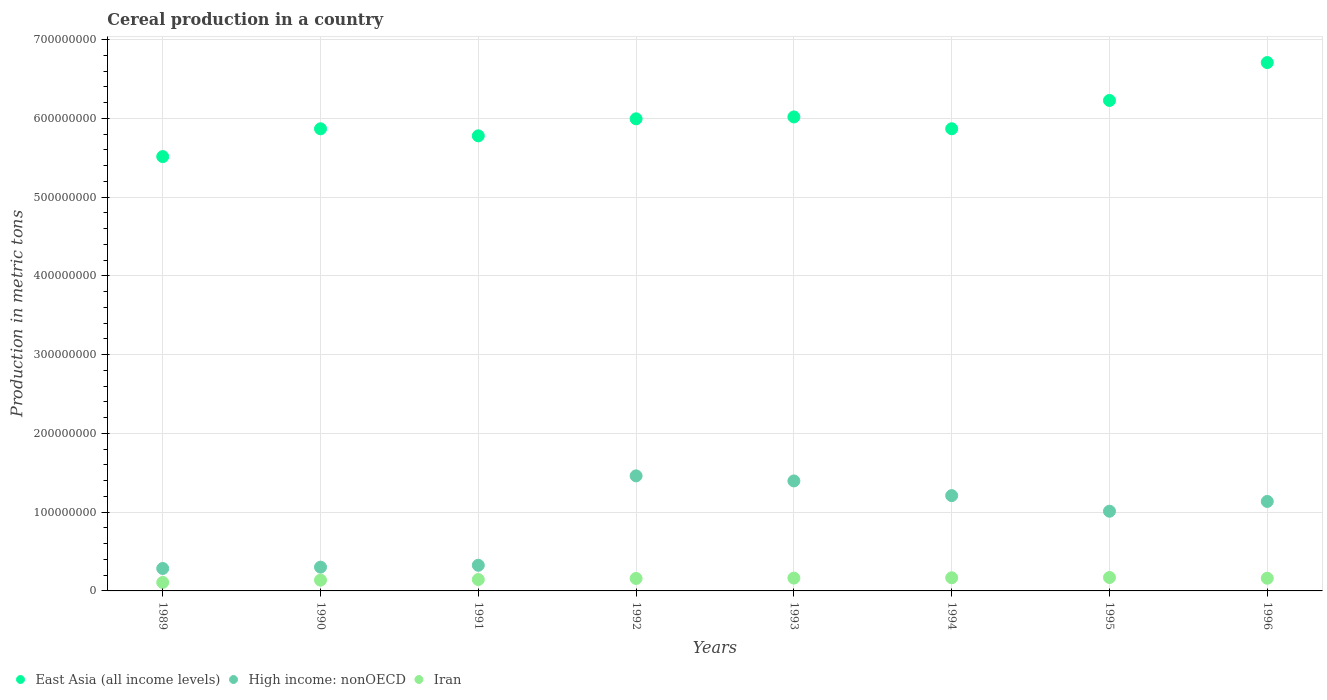What is the total cereal production in Iran in 1991?
Provide a succinct answer. 1.44e+07. Across all years, what is the maximum total cereal production in High income: nonOECD?
Provide a succinct answer. 1.46e+08. Across all years, what is the minimum total cereal production in East Asia (all income levels)?
Give a very brief answer. 5.52e+08. In which year was the total cereal production in Iran minimum?
Provide a succinct answer. 1989. What is the total total cereal production in High income: nonOECD in the graph?
Keep it short and to the point. 7.13e+08. What is the difference between the total cereal production in Iran in 1989 and that in 1996?
Ensure brevity in your answer.  -5.30e+06. What is the difference between the total cereal production in East Asia (all income levels) in 1994 and the total cereal production in High income: nonOECD in 1996?
Keep it short and to the point. 4.73e+08. What is the average total cereal production in High income: nonOECD per year?
Your response must be concise. 8.91e+07. In the year 1990, what is the difference between the total cereal production in East Asia (all income levels) and total cereal production in Iran?
Keep it short and to the point. 5.73e+08. In how many years, is the total cereal production in East Asia (all income levels) greater than 40000000 metric tons?
Keep it short and to the point. 8. What is the ratio of the total cereal production in High income: nonOECD in 1991 to that in 1995?
Your response must be concise. 0.32. Is the total cereal production in High income: nonOECD in 1994 less than that in 1996?
Offer a very short reply. No. Is the difference between the total cereal production in East Asia (all income levels) in 1990 and 1996 greater than the difference between the total cereal production in Iran in 1990 and 1996?
Your answer should be compact. No. What is the difference between the highest and the second highest total cereal production in High income: nonOECD?
Ensure brevity in your answer.  6.44e+06. What is the difference between the highest and the lowest total cereal production in Iran?
Offer a terse response. 6.25e+06. Is the sum of the total cereal production in East Asia (all income levels) in 1991 and 1992 greater than the maximum total cereal production in Iran across all years?
Offer a very short reply. Yes. Is it the case that in every year, the sum of the total cereal production in East Asia (all income levels) and total cereal production in High income: nonOECD  is greater than the total cereal production in Iran?
Your answer should be very brief. Yes. Is the total cereal production in East Asia (all income levels) strictly less than the total cereal production in High income: nonOECD over the years?
Give a very brief answer. No. How many dotlines are there?
Provide a short and direct response. 3. What is the difference between two consecutive major ticks on the Y-axis?
Your answer should be very brief. 1.00e+08. Are the values on the major ticks of Y-axis written in scientific E-notation?
Your answer should be very brief. No. Does the graph contain grids?
Ensure brevity in your answer.  Yes. How are the legend labels stacked?
Your answer should be very brief. Horizontal. What is the title of the graph?
Your answer should be compact. Cereal production in a country. Does "Tonga" appear as one of the legend labels in the graph?
Your answer should be compact. No. What is the label or title of the Y-axis?
Ensure brevity in your answer.  Production in metric tons. What is the Production in metric tons of East Asia (all income levels) in 1989?
Keep it short and to the point. 5.52e+08. What is the Production in metric tons of High income: nonOECD in 1989?
Provide a short and direct response. 2.85e+07. What is the Production in metric tons in Iran in 1989?
Make the answer very short. 1.08e+07. What is the Production in metric tons in East Asia (all income levels) in 1990?
Provide a succinct answer. 5.87e+08. What is the Production in metric tons of High income: nonOECD in 1990?
Keep it short and to the point. 3.02e+07. What is the Production in metric tons in Iran in 1990?
Offer a very short reply. 1.37e+07. What is the Production in metric tons in East Asia (all income levels) in 1991?
Provide a short and direct response. 5.78e+08. What is the Production in metric tons of High income: nonOECD in 1991?
Give a very brief answer. 3.26e+07. What is the Production in metric tons of Iran in 1991?
Offer a very short reply. 1.44e+07. What is the Production in metric tons of East Asia (all income levels) in 1992?
Your answer should be compact. 6.00e+08. What is the Production in metric tons of High income: nonOECD in 1992?
Make the answer very short. 1.46e+08. What is the Production in metric tons of Iran in 1992?
Your response must be concise. 1.58e+07. What is the Production in metric tons of East Asia (all income levels) in 1993?
Make the answer very short. 6.02e+08. What is the Production in metric tons in High income: nonOECD in 1993?
Ensure brevity in your answer.  1.40e+08. What is the Production in metric tons in Iran in 1993?
Your answer should be very brief. 1.63e+07. What is the Production in metric tons in East Asia (all income levels) in 1994?
Ensure brevity in your answer.  5.87e+08. What is the Production in metric tons of High income: nonOECD in 1994?
Your answer should be compact. 1.21e+08. What is the Production in metric tons of Iran in 1994?
Ensure brevity in your answer.  1.67e+07. What is the Production in metric tons of East Asia (all income levels) in 1995?
Ensure brevity in your answer.  6.23e+08. What is the Production in metric tons in High income: nonOECD in 1995?
Make the answer very short. 1.01e+08. What is the Production in metric tons in Iran in 1995?
Keep it short and to the point. 1.70e+07. What is the Production in metric tons of East Asia (all income levels) in 1996?
Make the answer very short. 6.71e+08. What is the Production in metric tons of High income: nonOECD in 1996?
Give a very brief answer. 1.14e+08. What is the Production in metric tons of Iran in 1996?
Your answer should be compact. 1.61e+07. Across all years, what is the maximum Production in metric tons in East Asia (all income levels)?
Provide a short and direct response. 6.71e+08. Across all years, what is the maximum Production in metric tons in High income: nonOECD?
Ensure brevity in your answer.  1.46e+08. Across all years, what is the maximum Production in metric tons in Iran?
Make the answer very short. 1.70e+07. Across all years, what is the minimum Production in metric tons of East Asia (all income levels)?
Provide a succinct answer. 5.52e+08. Across all years, what is the minimum Production in metric tons of High income: nonOECD?
Ensure brevity in your answer.  2.85e+07. Across all years, what is the minimum Production in metric tons in Iran?
Ensure brevity in your answer.  1.08e+07. What is the total Production in metric tons in East Asia (all income levels) in the graph?
Your answer should be very brief. 4.80e+09. What is the total Production in metric tons in High income: nonOECD in the graph?
Your answer should be very brief. 7.13e+08. What is the total Production in metric tons of Iran in the graph?
Give a very brief answer. 1.21e+08. What is the difference between the Production in metric tons of East Asia (all income levels) in 1989 and that in 1990?
Provide a short and direct response. -3.53e+07. What is the difference between the Production in metric tons in High income: nonOECD in 1989 and that in 1990?
Your response must be concise. -1.70e+06. What is the difference between the Production in metric tons in Iran in 1989 and that in 1990?
Give a very brief answer. -2.90e+06. What is the difference between the Production in metric tons of East Asia (all income levels) in 1989 and that in 1991?
Your response must be concise. -2.64e+07. What is the difference between the Production in metric tons of High income: nonOECD in 1989 and that in 1991?
Offer a terse response. -4.07e+06. What is the difference between the Production in metric tons of Iran in 1989 and that in 1991?
Ensure brevity in your answer.  -3.66e+06. What is the difference between the Production in metric tons of East Asia (all income levels) in 1989 and that in 1992?
Your answer should be very brief. -4.80e+07. What is the difference between the Production in metric tons of High income: nonOECD in 1989 and that in 1992?
Offer a terse response. -1.18e+08. What is the difference between the Production in metric tons in Iran in 1989 and that in 1992?
Make the answer very short. -5.02e+06. What is the difference between the Production in metric tons in East Asia (all income levels) in 1989 and that in 1993?
Your answer should be very brief. -5.04e+07. What is the difference between the Production in metric tons in High income: nonOECD in 1989 and that in 1993?
Your answer should be very brief. -1.11e+08. What is the difference between the Production in metric tons of Iran in 1989 and that in 1993?
Provide a succinct answer. -5.50e+06. What is the difference between the Production in metric tons in East Asia (all income levels) in 1989 and that in 1994?
Offer a very short reply. -3.54e+07. What is the difference between the Production in metric tons in High income: nonOECD in 1989 and that in 1994?
Give a very brief answer. -9.25e+07. What is the difference between the Production in metric tons in Iran in 1989 and that in 1994?
Make the answer very short. -5.90e+06. What is the difference between the Production in metric tons of East Asia (all income levels) in 1989 and that in 1995?
Give a very brief answer. -7.13e+07. What is the difference between the Production in metric tons in High income: nonOECD in 1989 and that in 1995?
Ensure brevity in your answer.  -7.27e+07. What is the difference between the Production in metric tons of Iran in 1989 and that in 1995?
Provide a succinct answer. -6.25e+06. What is the difference between the Production in metric tons in East Asia (all income levels) in 1989 and that in 1996?
Offer a terse response. -1.19e+08. What is the difference between the Production in metric tons of High income: nonOECD in 1989 and that in 1996?
Make the answer very short. -8.51e+07. What is the difference between the Production in metric tons of Iran in 1989 and that in 1996?
Keep it short and to the point. -5.30e+06. What is the difference between the Production in metric tons of East Asia (all income levels) in 1990 and that in 1991?
Make the answer very short. 8.95e+06. What is the difference between the Production in metric tons of High income: nonOECD in 1990 and that in 1991?
Your answer should be compact. -2.37e+06. What is the difference between the Production in metric tons in Iran in 1990 and that in 1991?
Provide a succinct answer. -7.63e+05. What is the difference between the Production in metric tons of East Asia (all income levels) in 1990 and that in 1992?
Ensure brevity in your answer.  -1.27e+07. What is the difference between the Production in metric tons in High income: nonOECD in 1990 and that in 1992?
Provide a short and direct response. -1.16e+08. What is the difference between the Production in metric tons in Iran in 1990 and that in 1992?
Your answer should be compact. -2.13e+06. What is the difference between the Production in metric tons of East Asia (all income levels) in 1990 and that in 1993?
Offer a terse response. -1.50e+07. What is the difference between the Production in metric tons of High income: nonOECD in 1990 and that in 1993?
Your answer should be compact. -1.09e+08. What is the difference between the Production in metric tons in Iran in 1990 and that in 1993?
Offer a terse response. -2.60e+06. What is the difference between the Production in metric tons in East Asia (all income levels) in 1990 and that in 1994?
Provide a succinct answer. -3.81e+04. What is the difference between the Production in metric tons in High income: nonOECD in 1990 and that in 1994?
Offer a terse response. -9.08e+07. What is the difference between the Production in metric tons in Iran in 1990 and that in 1994?
Your answer should be very brief. -3.01e+06. What is the difference between the Production in metric tons in East Asia (all income levels) in 1990 and that in 1995?
Provide a succinct answer. -3.60e+07. What is the difference between the Production in metric tons of High income: nonOECD in 1990 and that in 1995?
Provide a short and direct response. -7.10e+07. What is the difference between the Production in metric tons in Iran in 1990 and that in 1995?
Provide a short and direct response. -3.35e+06. What is the difference between the Production in metric tons of East Asia (all income levels) in 1990 and that in 1996?
Provide a short and direct response. -8.41e+07. What is the difference between the Production in metric tons in High income: nonOECD in 1990 and that in 1996?
Provide a succinct answer. -8.34e+07. What is the difference between the Production in metric tons in Iran in 1990 and that in 1996?
Offer a very short reply. -2.40e+06. What is the difference between the Production in metric tons in East Asia (all income levels) in 1991 and that in 1992?
Provide a short and direct response. -2.16e+07. What is the difference between the Production in metric tons in High income: nonOECD in 1991 and that in 1992?
Provide a succinct answer. -1.14e+08. What is the difference between the Production in metric tons in Iran in 1991 and that in 1992?
Give a very brief answer. -1.36e+06. What is the difference between the Production in metric tons in East Asia (all income levels) in 1991 and that in 1993?
Ensure brevity in your answer.  -2.40e+07. What is the difference between the Production in metric tons of High income: nonOECD in 1991 and that in 1993?
Your answer should be very brief. -1.07e+08. What is the difference between the Production in metric tons of Iran in 1991 and that in 1993?
Your answer should be compact. -1.84e+06. What is the difference between the Production in metric tons in East Asia (all income levels) in 1991 and that in 1994?
Your answer should be compact. -8.99e+06. What is the difference between the Production in metric tons of High income: nonOECD in 1991 and that in 1994?
Keep it short and to the point. -8.85e+07. What is the difference between the Production in metric tons in Iran in 1991 and that in 1994?
Ensure brevity in your answer.  -2.24e+06. What is the difference between the Production in metric tons in East Asia (all income levels) in 1991 and that in 1995?
Give a very brief answer. -4.49e+07. What is the difference between the Production in metric tons in High income: nonOECD in 1991 and that in 1995?
Your response must be concise. -6.86e+07. What is the difference between the Production in metric tons in Iran in 1991 and that in 1995?
Your answer should be very brief. -2.58e+06. What is the difference between the Production in metric tons in East Asia (all income levels) in 1991 and that in 1996?
Provide a short and direct response. -9.30e+07. What is the difference between the Production in metric tons in High income: nonOECD in 1991 and that in 1996?
Offer a terse response. -8.11e+07. What is the difference between the Production in metric tons in Iran in 1991 and that in 1996?
Offer a terse response. -1.64e+06. What is the difference between the Production in metric tons in East Asia (all income levels) in 1992 and that in 1993?
Provide a short and direct response. -2.39e+06. What is the difference between the Production in metric tons in High income: nonOECD in 1992 and that in 1993?
Your response must be concise. 6.44e+06. What is the difference between the Production in metric tons of Iran in 1992 and that in 1993?
Provide a short and direct response. -4.76e+05. What is the difference between the Production in metric tons of East Asia (all income levels) in 1992 and that in 1994?
Provide a succinct answer. 1.26e+07. What is the difference between the Production in metric tons of High income: nonOECD in 1992 and that in 1994?
Keep it short and to the point. 2.51e+07. What is the difference between the Production in metric tons in Iran in 1992 and that in 1994?
Your answer should be compact. -8.80e+05. What is the difference between the Production in metric tons of East Asia (all income levels) in 1992 and that in 1995?
Offer a very short reply. -2.33e+07. What is the difference between the Production in metric tons in High income: nonOECD in 1992 and that in 1995?
Provide a short and direct response. 4.49e+07. What is the difference between the Production in metric tons in Iran in 1992 and that in 1995?
Provide a short and direct response. -1.22e+06. What is the difference between the Production in metric tons of East Asia (all income levels) in 1992 and that in 1996?
Offer a terse response. -7.14e+07. What is the difference between the Production in metric tons in High income: nonOECD in 1992 and that in 1996?
Provide a short and direct response. 3.25e+07. What is the difference between the Production in metric tons in Iran in 1992 and that in 1996?
Provide a short and direct response. -2.72e+05. What is the difference between the Production in metric tons in East Asia (all income levels) in 1993 and that in 1994?
Make the answer very short. 1.50e+07. What is the difference between the Production in metric tons of High income: nonOECD in 1993 and that in 1994?
Keep it short and to the point. 1.86e+07. What is the difference between the Production in metric tons of Iran in 1993 and that in 1994?
Offer a terse response. -4.04e+05. What is the difference between the Production in metric tons of East Asia (all income levels) in 1993 and that in 1995?
Keep it short and to the point. -2.10e+07. What is the difference between the Production in metric tons of High income: nonOECD in 1993 and that in 1995?
Provide a succinct answer. 3.85e+07. What is the difference between the Production in metric tons in Iran in 1993 and that in 1995?
Give a very brief answer. -7.44e+05. What is the difference between the Production in metric tons of East Asia (all income levels) in 1993 and that in 1996?
Ensure brevity in your answer.  -6.91e+07. What is the difference between the Production in metric tons in High income: nonOECD in 1993 and that in 1996?
Offer a very short reply. 2.61e+07. What is the difference between the Production in metric tons of Iran in 1993 and that in 1996?
Your response must be concise. 2.04e+05. What is the difference between the Production in metric tons in East Asia (all income levels) in 1994 and that in 1995?
Keep it short and to the point. -3.60e+07. What is the difference between the Production in metric tons of High income: nonOECD in 1994 and that in 1995?
Offer a terse response. 1.98e+07. What is the difference between the Production in metric tons of Iran in 1994 and that in 1995?
Keep it short and to the point. -3.41e+05. What is the difference between the Production in metric tons in East Asia (all income levels) in 1994 and that in 1996?
Your answer should be very brief. -8.41e+07. What is the difference between the Production in metric tons of High income: nonOECD in 1994 and that in 1996?
Ensure brevity in your answer.  7.41e+06. What is the difference between the Production in metric tons of Iran in 1994 and that in 1996?
Provide a succinct answer. 6.08e+05. What is the difference between the Production in metric tons of East Asia (all income levels) in 1995 and that in 1996?
Offer a very short reply. -4.81e+07. What is the difference between the Production in metric tons of High income: nonOECD in 1995 and that in 1996?
Provide a short and direct response. -1.24e+07. What is the difference between the Production in metric tons of Iran in 1995 and that in 1996?
Ensure brevity in your answer.  9.49e+05. What is the difference between the Production in metric tons in East Asia (all income levels) in 1989 and the Production in metric tons in High income: nonOECD in 1990?
Give a very brief answer. 5.21e+08. What is the difference between the Production in metric tons of East Asia (all income levels) in 1989 and the Production in metric tons of Iran in 1990?
Offer a very short reply. 5.38e+08. What is the difference between the Production in metric tons in High income: nonOECD in 1989 and the Production in metric tons in Iran in 1990?
Your response must be concise. 1.48e+07. What is the difference between the Production in metric tons in East Asia (all income levels) in 1989 and the Production in metric tons in High income: nonOECD in 1991?
Your answer should be compact. 5.19e+08. What is the difference between the Production in metric tons of East Asia (all income levels) in 1989 and the Production in metric tons of Iran in 1991?
Offer a terse response. 5.37e+08. What is the difference between the Production in metric tons of High income: nonOECD in 1989 and the Production in metric tons of Iran in 1991?
Provide a succinct answer. 1.40e+07. What is the difference between the Production in metric tons in East Asia (all income levels) in 1989 and the Production in metric tons in High income: nonOECD in 1992?
Your response must be concise. 4.05e+08. What is the difference between the Production in metric tons of East Asia (all income levels) in 1989 and the Production in metric tons of Iran in 1992?
Provide a succinct answer. 5.36e+08. What is the difference between the Production in metric tons of High income: nonOECD in 1989 and the Production in metric tons of Iran in 1992?
Keep it short and to the point. 1.27e+07. What is the difference between the Production in metric tons in East Asia (all income levels) in 1989 and the Production in metric tons in High income: nonOECD in 1993?
Keep it short and to the point. 4.12e+08. What is the difference between the Production in metric tons of East Asia (all income levels) in 1989 and the Production in metric tons of Iran in 1993?
Your answer should be compact. 5.35e+08. What is the difference between the Production in metric tons in High income: nonOECD in 1989 and the Production in metric tons in Iran in 1993?
Your response must be concise. 1.22e+07. What is the difference between the Production in metric tons in East Asia (all income levels) in 1989 and the Production in metric tons in High income: nonOECD in 1994?
Your answer should be compact. 4.31e+08. What is the difference between the Production in metric tons of East Asia (all income levels) in 1989 and the Production in metric tons of Iran in 1994?
Ensure brevity in your answer.  5.35e+08. What is the difference between the Production in metric tons of High income: nonOECD in 1989 and the Production in metric tons of Iran in 1994?
Ensure brevity in your answer.  1.18e+07. What is the difference between the Production in metric tons in East Asia (all income levels) in 1989 and the Production in metric tons in High income: nonOECD in 1995?
Your response must be concise. 4.50e+08. What is the difference between the Production in metric tons in East Asia (all income levels) in 1989 and the Production in metric tons in Iran in 1995?
Your response must be concise. 5.35e+08. What is the difference between the Production in metric tons of High income: nonOECD in 1989 and the Production in metric tons of Iran in 1995?
Ensure brevity in your answer.  1.15e+07. What is the difference between the Production in metric tons in East Asia (all income levels) in 1989 and the Production in metric tons in High income: nonOECD in 1996?
Offer a very short reply. 4.38e+08. What is the difference between the Production in metric tons of East Asia (all income levels) in 1989 and the Production in metric tons of Iran in 1996?
Give a very brief answer. 5.35e+08. What is the difference between the Production in metric tons of High income: nonOECD in 1989 and the Production in metric tons of Iran in 1996?
Offer a very short reply. 1.24e+07. What is the difference between the Production in metric tons in East Asia (all income levels) in 1990 and the Production in metric tons in High income: nonOECD in 1991?
Provide a short and direct response. 5.54e+08. What is the difference between the Production in metric tons of East Asia (all income levels) in 1990 and the Production in metric tons of Iran in 1991?
Offer a very short reply. 5.72e+08. What is the difference between the Production in metric tons of High income: nonOECD in 1990 and the Production in metric tons of Iran in 1991?
Keep it short and to the point. 1.57e+07. What is the difference between the Production in metric tons in East Asia (all income levels) in 1990 and the Production in metric tons in High income: nonOECD in 1992?
Your answer should be very brief. 4.41e+08. What is the difference between the Production in metric tons of East Asia (all income levels) in 1990 and the Production in metric tons of Iran in 1992?
Your answer should be very brief. 5.71e+08. What is the difference between the Production in metric tons in High income: nonOECD in 1990 and the Production in metric tons in Iran in 1992?
Your answer should be compact. 1.44e+07. What is the difference between the Production in metric tons of East Asia (all income levels) in 1990 and the Production in metric tons of High income: nonOECD in 1993?
Keep it short and to the point. 4.47e+08. What is the difference between the Production in metric tons in East Asia (all income levels) in 1990 and the Production in metric tons in Iran in 1993?
Make the answer very short. 5.71e+08. What is the difference between the Production in metric tons in High income: nonOECD in 1990 and the Production in metric tons in Iran in 1993?
Give a very brief answer. 1.39e+07. What is the difference between the Production in metric tons of East Asia (all income levels) in 1990 and the Production in metric tons of High income: nonOECD in 1994?
Offer a terse response. 4.66e+08. What is the difference between the Production in metric tons in East Asia (all income levels) in 1990 and the Production in metric tons in Iran in 1994?
Your response must be concise. 5.70e+08. What is the difference between the Production in metric tons of High income: nonOECD in 1990 and the Production in metric tons of Iran in 1994?
Give a very brief answer. 1.35e+07. What is the difference between the Production in metric tons of East Asia (all income levels) in 1990 and the Production in metric tons of High income: nonOECD in 1995?
Offer a very short reply. 4.86e+08. What is the difference between the Production in metric tons of East Asia (all income levels) in 1990 and the Production in metric tons of Iran in 1995?
Make the answer very short. 5.70e+08. What is the difference between the Production in metric tons in High income: nonOECD in 1990 and the Production in metric tons in Iran in 1995?
Your answer should be compact. 1.32e+07. What is the difference between the Production in metric tons of East Asia (all income levels) in 1990 and the Production in metric tons of High income: nonOECD in 1996?
Keep it short and to the point. 4.73e+08. What is the difference between the Production in metric tons in East Asia (all income levels) in 1990 and the Production in metric tons in Iran in 1996?
Your response must be concise. 5.71e+08. What is the difference between the Production in metric tons of High income: nonOECD in 1990 and the Production in metric tons of Iran in 1996?
Provide a succinct answer. 1.41e+07. What is the difference between the Production in metric tons of East Asia (all income levels) in 1991 and the Production in metric tons of High income: nonOECD in 1992?
Keep it short and to the point. 4.32e+08. What is the difference between the Production in metric tons in East Asia (all income levels) in 1991 and the Production in metric tons in Iran in 1992?
Provide a succinct answer. 5.62e+08. What is the difference between the Production in metric tons in High income: nonOECD in 1991 and the Production in metric tons in Iran in 1992?
Your response must be concise. 1.68e+07. What is the difference between the Production in metric tons of East Asia (all income levels) in 1991 and the Production in metric tons of High income: nonOECD in 1993?
Offer a terse response. 4.38e+08. What is the difference between the Production in metric tons of East Asia (all income levels) in 1991 and the Production in metric tons of Iran in 1993?
Provide a short and direct response. 5.62e+08. What is the difference between the Production in metric tons in High income: nonOECD in 1991 and the Production in metric tons in Iran in 1993?
Offer a terse response. 1.63e+07. What is the difference between the Production in metric tons in East Asia (all income levels) in 1991 and the Production in metric tons in High income: nonOECD in 1994?
Provide a short and direct response. 4.57e+08. What is the difference between the Production in metric tons of East Asia (all income levels) in 1991 and the Production in metric tons of Iran in 1994?
Your response must be concise. 5.61e+08. What is the difference between the Production in metric tons of High income: nonOECD in 1991 and the Production in metric tons of Iran in 1994?
Your response must be concise. 1.59e+07. What is the difference between the Production in metric tons in East Asia (all income levels) in 1991 and the Production in metric tons in High income: nonOECD in 1995?
Offer a very short reply. 4.77e+08. What is the difference between the Production in metric tons in East Asia (all income levels) in 1991 and the Production in metric tons in Iran in 1995?
Keep it short and to the point. 5.61e+08. What is the difference between the Production in metric tons of High income: nonOECD in 1991 and the Production in metric tons of Iran in 1995?
Offer a terse response. 1.55e+07. What is the difference between the Production in metric tons in East Asia (all income levels) in 1991 and the Production in metric tons in High income: nonOECD in 1996?
Your response must be concise. 4.64e+08. What is the difference between the Production in metric tons in East Asia (all income levels) in 1991 and the Production in metric tons in Iran in 1996?
Your answer should be compact. 5.62e+08. What is the difference between the Production in metric tons in High income: nonOECD in 1991 and the Production in metric tons in Iran in 1996?
Offer a terse response. 1.65e+07. What is the difference between the Production in metric tons of East Asia (all income levels) in 1992 and the Production in metric tons of High income: nonOECD in 1993?
Provide a succinct answer. 4.60e+08. What is the difference between the Production in metric tons in East Asia (all income levels) in 1992 and the Production in metric tons in Iran in 1993?
Give a very brief answer. 5.83e+08. What is the difference between the Production in metric tons in High income: nonOECD in 1992 and the Production in metric tons in Iran in 1993?
Keep it short and to the point. 1.30e+08. What is the difference between the Production in metric tons in East Asia (all income levels) in 1992 and the Production in metric tons in High income: nonOECD in 1994?
Give a very brief answer. 4.79e+08. What is the difference between the Production in metric tons in East Asia (all income levels) in 1992 and the Production in metric tons in Iran in 1994?
Make the answer very short. 5.83e+08. What is the difference between the Production in metric tons in High income: nonOECD in 1992 and the Production in metric tons in Iran in 1994?
Make the answer very short. 1.29e+08. What is the difference between the Production in metric tons of East Asia (all income levels) in 1992 and the Production in metric tons of High income: nonOECD in 1995?
Keep it short and to the point. 4.98e+08. What is the difference between the Production in metric tons of East Asia (all income levels) in 1992 and the Production in metric tons of Iran in 1995?
Ensure brevity in your answer.  5.83e+08. What is the difference between the Production in metric tons of High income: nonOECD in 1992 and the Production in metric tons of Iran in 1995?
Provide a short and direct response. 1.29e+08. What is the difference between the Production in metric tons of East Asia (all income levels) in 1992 and the Production in metric tons of High income: nonOECD in 1996?
Provide a succinct answer. 4.86e+08. What is the difference between the Production in metric tons of East Asia (all income levels) in 1992 and the Production in metric tons of Iran in 1996?
Offer a very short reply. 5.83e+08. What is the difference between the Production in metric tons in High income: nonOECD in 1992 and the Production in metric tons in Iran in 1996?
Offer a very short reply. 1.30e+08. What is the difference between the Production in metric tons in East Asia (all income levels) in 1993 and the Production in metric tons in High income: nonOECD in 1994?
Provide a short and direct response. 4.81e+08. What is the difference between the Production in metric tons of East Asia (all income levels) in 1993 and the Production in metric tons of Iran in 1994?
Ensure brevity in your answer.  5.85e+08. What is the difference between the Production in metric tons of High income: nonOECD in 1993 and the Production in metric tons of Iran in 1994?
Provide a succinct answer. 1.23e+08. What is the difference between the Production in metric tons in East Asia (all income levels) in 1993 and the Production in metric tons in High income: nonOECD in 1995?
Provide a succinct answer. 5.01e+08. What is the difference between the Production in metric tons of East Asia (all income levels) in 1993 and the Production in metric tons of Iran in 1995?
Offer a very short reply. 5.85e+08. What is the difference between the Production in metric tons in High income: nonOECD in 1993 and the Production in metric tons in Iran in 1995?
Ensure brevity in your answer.  1.23e+08. What is the difference between the Production in metric tons of East Asia (all income levels) in 1993 and the Production in metric tons of High income: nonOECD in 1996?
Give a very brief answer. 4.88e+08. What is the difference between the Production in metric tons of East Asia (all income levels) in 1993 and the Production in metric tons of Iran in 1996?
Make the answer very short. 5.86e+08. What is the difference between the Production in metric tons in High income: nonOECD in 1993 and the Production in metric tons in Iran in 1996?
Provide a succinct answer. 1.24e+08. What is the difference between the Production in metric tons of East Asia (all income levels) in 1994 and the Production in metric tons of High income: nonOECD in 1995?
Give a very brief answer. 4.86e+08. What is the difference between the Production in metric tons of East Asia (all income levels) in 1994 and the Production in metric tons of Iran in 1995?
Your answer should be very brief. 5.70e+08. What is the difference between the Production in metric tons of High income: nonOECD in 1994 and the Production in metric tons of Iran in 1995?
Offer a terse response. 1.04e+08. What is the difference between the Production in metric tons in East Asia (all income levels) in 1994 and the Production in metric tons in High income: nonOECD in 1996?
Ensure brevity in your answer.  4.73e+08. What is the difference between the Production in metric tons of East Asia (all income levels) in 1994 and the Production in metric tons of Iran in 1996?
Offer a very short reply. 5.71e+08. What is the difference between the Production in metric tons of High income: nonOECD in 1994 and the Production in metric tons of Iran in 1996?
Provide a short and direct response. 1.05e+08. What is the difference between the Production in metric tons in East Asia (all income levels) in 1995 and the Production in metric tons in High income: nonOECD in 1996?
Provide a short and direct response. 5.09e+08. What is the difference between the Production in metric tons in East Asia (all income levels) in 1995 and the Production in metric tons in Iran in 1996?
Your answer should be compact. 6.07e+08. What is the difference between the Production in metric tons of High income: nonOECD in 1995 and the Production in metric tons of Iran in 1996?
Offer a terse response. 8.51e+07. What is the average Production in metric tons in East Asia (all income levels) per year?
Offer a very short reply. 6.00e+08. What is the average Production in metric tons in High income: nonOECD per year?
Provide a short and direct response. 8.91e+07. What is the average Production in metric tons in Iran per year?
Your response must be concise. 1.51e+07. In the year 1989, what is the difference between the Production in metric tons of East Asia (all income levels) and Production in metric tons of High income: nonOECD?
Ensure brevity in your answer.  5.23e+08. In the year 1989, what is the difference between the Production in metric tons in East Asia (all income levels) and Production in metric tons in Iran?
Provide a succinct answer. 5.41e+08. In the year 1989, what is the difference between the Production in metric tons of High income: nonOECD and Production in metric tons of Iran?
Ensure brevity in your answer.  1.77e+07. In the year 1990, what is the difference between the Production in metric tons in East Asia (all income levels) and Production in metric tons in High income: nonOECD?
Give a very brief answer. 5.57e+08. In the year 1990, what is the difference between the Production in metric tons of East Asia (all income levels) and Production in metric tons of Iran?
Provide a short and direct response. 5.73e+08. In the year 1990, what is the difference between the Production in metric tons in High income: nonOECD and Production in metric tons in Iran?
Provide a succinct answer. 1.65e+07. In the year 1991, what is the difference between the Production in metric tons in East Asia (all income levels) and Production in metric tons in High income: nonOECD?
Your response must be concise. 5.45e+08. In the year 1991, what is the difference between the Production in metric tons of East Asia (all income levels) and Production in metric tons of Iran?
Provide a short and direct response. 5.63e+08. In the year 1991, what is the difference between the Production in metric tons in High income: nonOECD and Production in metric tons in Iran?
Ensure brevity in your answer.  1.81e+07. In the year 1992, what is the difference between the Production in metric tons in East Asia (all income levels) and Production in metric tons in High income: nonOECD?
Your answer should be compact. 4.53e+08. In the year 1992, what is the difference between the Production in metric tons in East Asia (all income levels) and Production in metric tons in Iran?
Your answer should be very brief. 5.84e+08. In the year 1992, what is the difference between the Production in metric tons of High income: nonOECD and Production in metric tons of Iran?
Provide a succinct answer. 1.30e+08. In the year 1993, what is the difference between the Production in metric tons of East Asia (all income levels) and Production in metric tons of High income: nonOECD?
Provide a short and direct response. 4.62e+08. In the year 1993, what is the difference between the Production in metric tons of East Asia (all income levels) and Production in metric tons of Iran?
Your answer should be very brief. 5.86e+08. In the year 1993, what is the difference between the Production in metric tons of High income: nonOECD and Production in metric tons of Iran?
Provide a succinct answer. 1.23e+08. In the year 1994, what is the difference between the Production in metric tons in East Asia (all income levels) and Production in metric tons in High income: nonOECD?
Ensure brevity in your answer.  4.66e+08. In the year 1994, what is the difference between the Production in metric tons in East Asia (all income levels) and Production in metric tons in Iran?
Keep it short and to the point. 5.70e+08. In the year 1994, what is the difference between the Production in metric tons of High income: nonOECD and Production in metric tons of Iran?
Keep it short and to the point. 1.04e+08. In the year 1995, what is the difference between the Production in metric tons in East Asia (all income levels) and Production in metric tons in High income: nonOECD?
Offer a very short reply. 5.22e+08. In the year 1995, what is the difference between the Production in metric tons in East Asia (all income levels) and Production in metric tons in Iran?
Provide a short and direct response. 6.06e+08. In the year 1995, what is the difference between the Production in metric tons in High income: nonOECD and Production in metric tons in Iran?
Provide a succinct answer. 8.42e+07. In the year 1996, what is the difference between the Production in metric tons in East Asia (all income levels) and Production in metric tons in High income: nonOECD?
Offer a very short reply. 5.57e+08. In the year 1996, what is the difference between the Production in metric tons of East Asia (all income levels) and Production in metric tons of Iran?
Provide a short and direct response. 6.55e+08. In the year 1996, what is the difference between the Production in metric tons in High income: nonOECD and Production in metric tons in Iran?
Keep it short and to the point. 9.75e+07. What is the ratio of the Production in metric tons in East Asia (all income levels) in 1989 to that in 1990?
Provide a short and direct response. 0.94. What is the ratio of the Production in metric tons in High income: nonOECD in 1989 to that in 1990?
Keep it short and to the point. 0.94. What is the ratio of the Production in metric tons in Iran in 1989 to that in 1990?
Ensure brevity in your answer.  0.79. What is the ratio of the Production in metric tons in East Asia (all income levels) in 1989 to that in 1991?
Your response must be concise. 0.95. What is the ratio of the Production in metric tons of High income: nonOECD in 1989 to that in 1991?
Your response must be concise. 0.88. What is the ratio of the Production in metric tons of Iran in 1989 to that in 1991?
Your answer should be very brief. 0.75. What is the ratio of the Production in metric tons in East Asia (all income levels) in 1989 to that in 1992?
Ensure brevity in your answer.  0.92. What is the ratio of the Production in metric tons of High income: nonOECD in 1989 to that in 1992?
Provide a short and direct response. 0.2. What is the ratio of the Production in metric tons in Iran in 1989 to that in 1992?
Give a very brief answer. 0.68. What is the ratio of the Production in metric tons of East Asia (all income levels) in 1989 to that in 1993?
Make the answer very short. 0.92. What is the ratio of the Production in metric tons in High income: nonOECD in 1989 to that in 1993?
Provide a short and direct response. 0.2. What is the ratio of the Production in metric tons of Iran in 1989 to that in 1993?
Offer a very short reply. 0.66. What is the ratio of the Production in metric tons of East Asia (all income levels) in 1989 to that in 1994?
Your answer should be compact. 0.94. What is the ratio of the Production in metric tons of High income: nonOECD in 1989 to that in 1994?
Make the answer very short. 0.24. What is the ratio of the Production in metric tons in Iran in 1989 to that in 1994?
Offer a terse response. 0.65. What is the ratio of the Production in metric tons in East Asia (all income levels) in 1989 to that in 1995?
Keep it short and to the point. 0.89. What is the ratio of the Production in metric tons of High income: nonOECD in 1989 to that in 1995?
Offer a terse response. 0.28. What is the ratio of the Production in metric tons in Iran in 1989 to that in 1995?
Your answer should be compact. 0.63. What is the ratio of the Production in metric tons in East Asia (all income levels) in 1989 to that in 1996?
Give a very brief answer. 0.82. What is the ratio of the Production in metric tons in High income: nonOECD in 1989 to that in 1996?
Keep it short and to the point. 0.25. What is the ratio of the Production in metric tons in Iran in 1989 to that in 1996?
Provide a short and direct response. 0.67. What is the ratio of the Production in metric tons of East Asia (all income levels) in 1990 to that in 1991?
Offer a very short reply. 1.02. What is the ratio of the Production in metric tons of High income: nonOECD in 1990 to that in 1991?
Provide a succinct answer. 0.93. What is the ratio of the Production in metric tons in Iran in 1990 to that in 1991?
Make the answer very short. 0.95. What is the ratio of the Production in metric tons in East Asia (all income levels) in 1990 to that in 1992?
Provide a succinct answer. 0.98. What is the ratio of the Production in metric tons of High income: nonOECD in 1990 to that in 1992?
Give a very brief answer. 0.21. What is the ratio of the Production in metric tons of Iran in 1990 to that in 1992?
Provide a succinct answer. 0.87. What is the ratio of the Production in metric tons in High income: nonOECD in 1990 to that in 1993?
Your answer should be compact. 0.22. What is the ratio of the Production in metric tons in Iran in 1990 to that in 1993?
Your answer should be compact. 0.84. What is the ratio of the Production in metric tons of High income: nonOECD in 1990 to that in 1994?
Ensure brevity in your answer.  0.25. What is the ratio of the Production in metric tons in Iran in 1990 to that in 1994?
Make the answer very short. 0.82. What is the ratio of the Production in metric tons in East Asia (all income levels) in 1990 to that in 1995?
Your answer should be very brief. 0.94. What is the ratio of the Production in metric tons in High income: nonOECD in 1990 to that in 1995?
Ensure brevity in your answer.  0.3. What is the ratio of the Production in metric tons in Iran in 1990 to that in 1995?
Your answer should be compact. 0.8. What is the ratio of the Production in metric tons in East Asia (all income levels) in 1990 to that in 1996?
Give a very brief answer. 0.87. What is the ratio of the Production in metric tons in High income: nonOECD in 1990 to that in 1996?
Make the answer very short. 0.27. What is the ratio of the Production in metric tons in Iran in 1990 to that in 1996?
Keep it short and to the point. 0.85. What is the ratio of the Production in metric tons of High income: nonOECD in 1991 to that in 1992?
Ensure brevity in your answer.  0.22. What is the ratio of the Production in metric tons in Iran in 1991 to that in 1992?
Provide a short and direct response. 0.91. What is the ratio of the Production in metric tons of East Asia (all income levels) in 1991 to that in 1993?
Give a very brief answer. 0.96. What is the ratio of the Production in metric tons of High income: nonOECD in 1991 to that in 1993?
Give a very brief answer. 0.23. What is the ratio of the Production in metric tons of Iran in 1991 to that in 1993?
Your answer should be compact. 0.89. What is the ratio of the Production in metric tons in East Asia (all income levels) in 1991 to that in 1994?
Offer a very short reply. 0.98. What is the ratio of the Production in metric tons in High income: nonOECD in 1991 to that in 1994?
Your answer should be compact. 0.27. What is the ratio of the Production in metric tons of Iran in 1991 to that in 1994?
Your response must be concise. 0.87. What is the ratio of the Production in metric tons in East Asia (all income levels) in 1991 to that in 1995?
Keep it short and to the point. 0.93. What is the ratio of the Production in metric tons in High income: nonOECD in 1991 to that in 1995?
Keep it short and to the point. 0.32. What is the ratio of the Production in metric tons of Iran in 1991 to that in 1995?
Give a very brief answer. 0.85. What is the ratio of the Production in metric tons of East Asia (all income levels) in 1991 to that in 1996?
Ensure brevity in your answer.  0.86. What is the ratio of the Production in metric tons in High income: nonOECD in 1991 to that in 1996?
Ensure brevity in your answer.  0.29. What is the ratio of the Production in metric tons in Iran in 1991 to that in 1996?
Make the answer very short. 0.9. What is the ratio of the Production in metric tons in High income: nonOECD in 1992 to that in 1993?
Offer a terse response. 1.05. What is the ratio of the Production in metric tons in Iran in 1992 to that in 1993?
Offer a terse response. 0.97. What is the ratio of the Production in metric tons in East Asia (all income levels) in 1992 to that in 1994?
Your answer should be very brief. 1.02. What is the ratio of the Production in metric tons in High income: nonOECD in 1992 to that in 1994?
Your answer should be compact. 1.21. What is the ratio of the Production in metric tons in Iran in 1992 to that in 1994?
Your answer should be compact. 0.95. What is the ratio of the Production in metric tons in East Asia (all income levels) in 1992 to that in 1995?
Offer a terse response. 0.96. What is the ratio of the Production in metric tons in High income: nonOECD in 1992 to that in 1995?
Provide a short and direct response. 1.44. What is the ratio of the Production in metric tons of Iran in 1992 to that in 1995?
Make the answer very short. 0.93. What is the ratio of the Production in metric tons in East Asia (all income levels) in 1992 to that in 1996?
Offer a terse response. 0.89. What is the ratio of the Production in metric tons in High income: nonOECD in 1992 to that in 1996?
Ensure brevity in your answer.  1.29. What is the ratio of the Production in metric tons of Iran in 1992 to that in 1996?
Your response must be concise. 0.98. What is the ratio of the Production in metric tons of East Asia (all income levels) in 1993 to that in 1994?
Your answer should be compact. 1.03. What is the ratio of the Production in metric tons of High income: nonOECD in 1993 to that in 1994?
Your answer should be compact. 1.15. What is the ratio of the Production in metric tons of Iran in 1993 to that in 1994?
Keep it short and to the point. 0.98. What is the ratio of the Production in metric tons of East Asia (all income levels) in 1993 to that in 1995?
Give a very brief answer. 0.97. What is the ratio of the Production in metric tons of High income: nonOECD in 1993 to that in 1995?
Your answer should be very brief. 1.38. What is the ratio of the Production in metric tons in Iran in 1993 to that in 1995?
Provide a short and direct response. 0.96. What is the ratio of the Production in metric tons in East Asia (all income levels) in 1993 to that in 1996?
Your response must be concise. 0.9. What is the ratio of the Production in metric tons of High income: nonOECD in 1993 to that in 1996?
Your answer should be very brief. 1.23. What is the ratio of the Production in metric tons in Iran in 1993 to that in 1996?
Provide a succinct answer. 1.01. What is the ratio of the Production in metric tons in East Asia (all income levels) in 1994 to that in 1995?
Give a very brief answer. 0.94. What is the ratio of the Production in metric tons in High income: nonOECD in 1994 to that in 1995?
Ensure brevity in your answer.  1.2. What is the ratio of the Production in metric tons in East Asia (all income levels) in 1994 to that in 1996?
Provide a short and direct response. 0.87. What is the ratio of the Production in metric tons in High income: nonOECD in 1994 to that in 1996?
Give a very brief answer. 1.07. What is the ratio of the Production in metric tons of Iran in 1994 to that in 1996?
Ensure brevity in your answer.  1.04. What is the ratio of the Production in metric tons of East Asia (all income levels) in 1995 to that in 1996?
Offer a terse response. 0.93. What is the ratio of the Production in metric tons of High income: nonOECD in 1995 to that in 1996?
Offer a terse response. 0.89. What is the ratio of the Production in metric tons of Iran in 1995 to that in 1996?
Make the answer very short. 1.06. What is the difference between the highest and the second highest Production in metric tons in East Asia (all income levels)?
Offer a terse response. 4.81e+07. What is the difference between the highest and the second highest Production in metric tons in High income: nonOECD?
Provide a succinct answer. 6.44e+06. What is the difference between the highest and the second highest Production in metric tons of Iran?
Ensure brevity in your answer.  3.41e+05. What is the difference between the highest and the lowest Production in metric tons in East Asia (all income levels)?
Offer a very short reply. 1.19e+08. What is the difference between the highest and the lowest Production in metric tons of High income: nonOECD?
Provide a succinct answer. 1.18e+08. What is the difference between the highest and the lowest Production in metric tons in Iran?
Make the answer very short. 6.25e+06. 